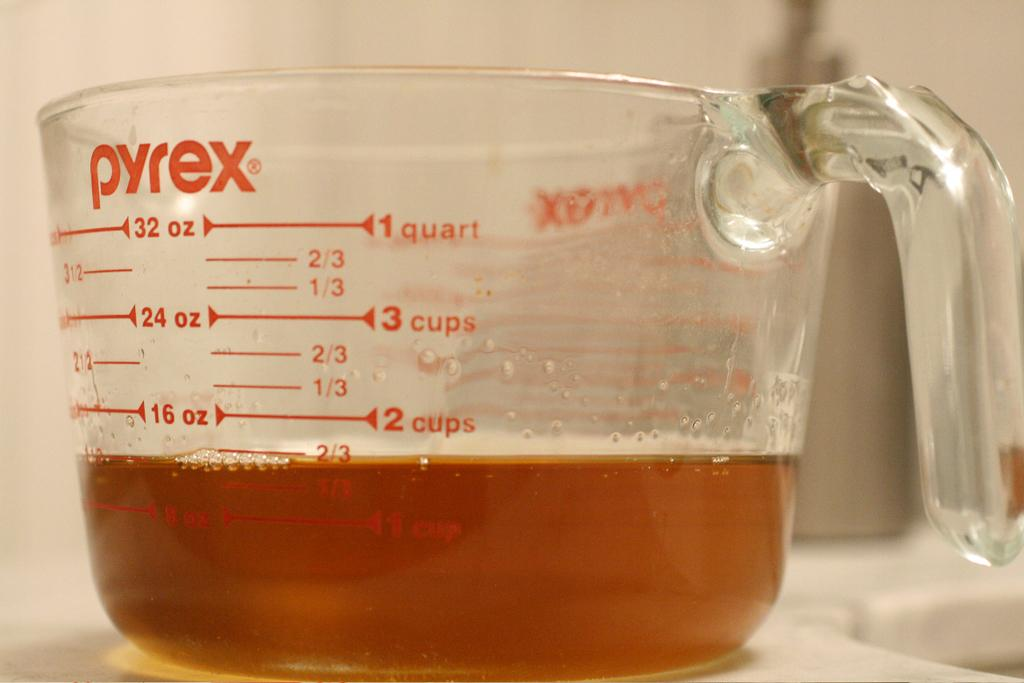<image>
Share a concise interpretation of the image provided. A Pyrex measuring cup is labeled with quart and cup measurements. 